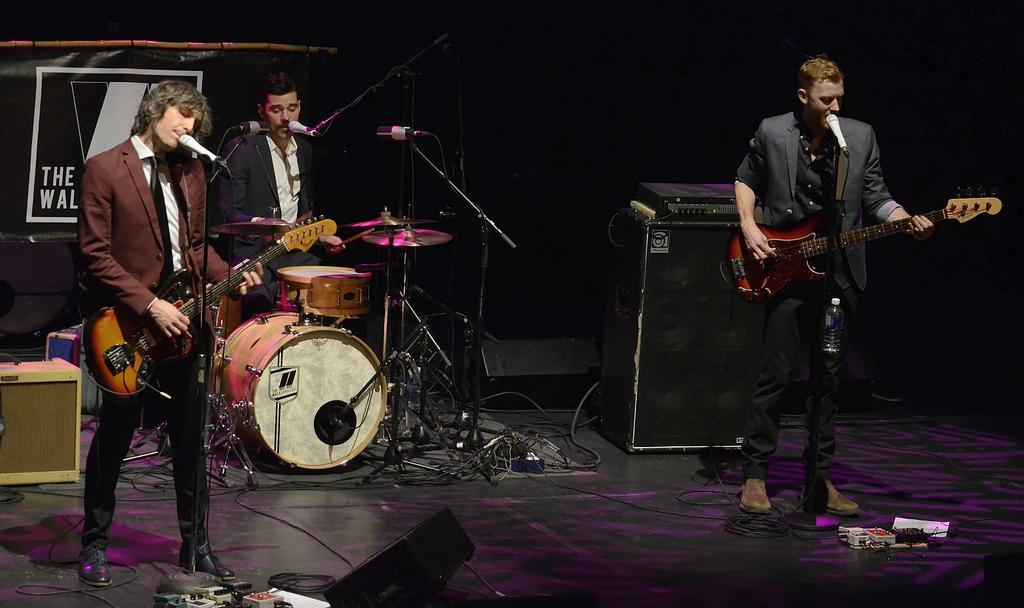Please provide a concise description of this image. In this image there are three persons. The person to the right side is playing the guitar while singing with the mic. The person the left side is also playing the guitar and singing and the person at the back side is beating the drums and singing with the mic which is in front of him. At the back side there is a banner. 